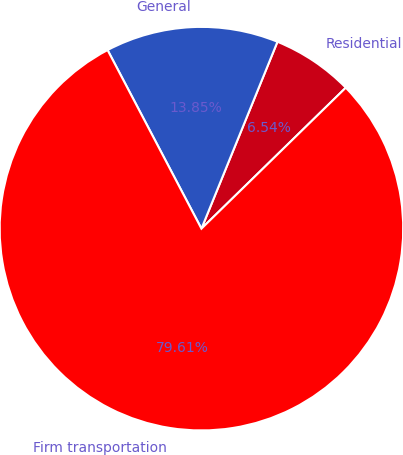Convert chart to OTSL. <chart><loc_0><loc_0><loc_500><loc_500><pie_chart><fcel>Residential<fcel>General<fcel>Firm transportation<nl><fcel>6.54%<fcel>13.85%<fcel>79.61%<nl></chart> 